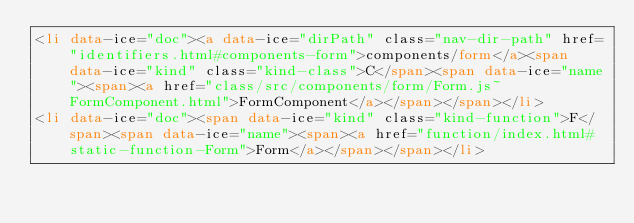Convert code to text. <code><loc_0><loc_0><loc_500><loc_500><_HTML_><li data-ice="doc"><a data-ice="dirPath" class="nav-dir-path" href="identifiers.html#components-form">components/form</a><span data-ice="kind" class="kind-class">C</span><span data-ice="name"><span><a href="class/src/components/form/Form.js~FormComponent.html">FormComponent</a></span></span></li>
<li data-ice="doc"><span data-ice="kind" class="kind-function">F</span><span data-ice="name"><span><a href="function/index.html#static-function-Form">Form</a></span></span></li></code> 